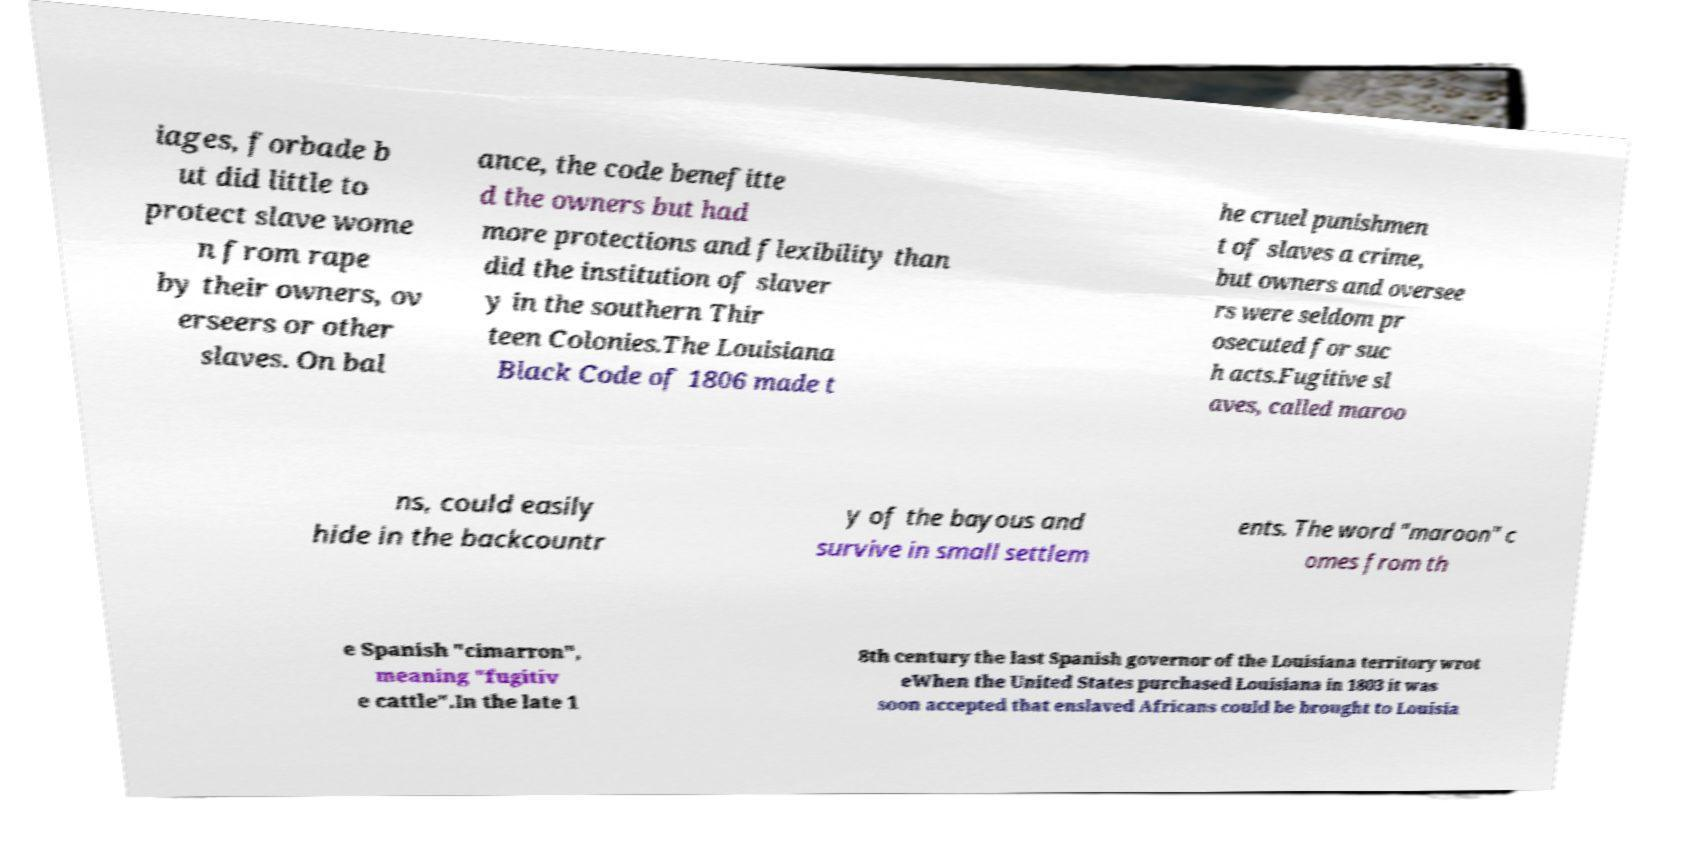Can you read and provide the text displayed in the image?This photo seems to have some interesting text. Can you extract and type it out for me? iages, forbade b ut did little to protect slave wome n from rape by their owners, ov erseers or other slaves. On bal ance, the code benefitte d the owners but had more protections and flexibility than did the institution of slaver y in the southern Thir teen Colonies.The Louisiana Black Code of 1806 made t he cruel punishmen t of slaves a crime, but owners and oversee rs were seldom pr osecuted for suc h acts.Fugitive sl aves, called maroo ns, could easily hide in the backcountr y of the bayous and survive in small settlem ents. The word "maroon" c omes from th e Spanish "cimarron", meaning "fugitiv e cattle".In the late 1 8th century the last Spanish governor of the Louisiana territory wrot eWhen the United States purchased Louisiana in 1803 it was soon accepted that enslaved Africans could be brought to Louisia 